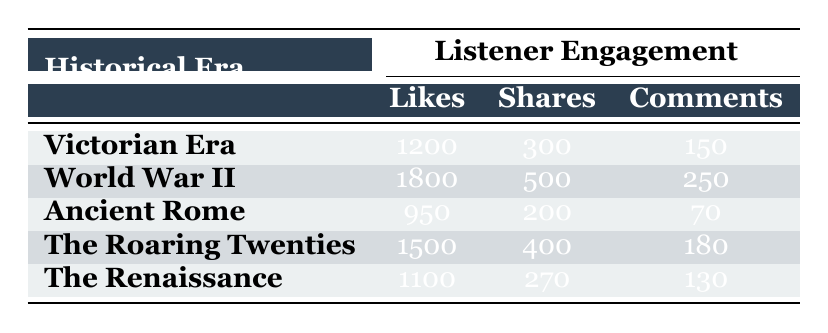What is the total number of likes for the podcast episodes about the Victorian Era and the Roaring Twenties combined? The number of likes for the Victorian Era episode "The Mysteries of Victorian London" is 1200, and for "Jazz and Prohibition" from the Roaring Twenties is 1500. Adding these together gives us 1200 + 1500 = 2700.
Answer: 2700 Which historical era received the lowest number of comments? By comparing the comments for each episode, the Victorian Era has 150 comments, World War II has 250, Ancient Rome has 70, The Roaring Twenties has 180, and The Renaissance has 130. The minimum among these numbers is 70 from Ancient Rome.
Answer: Ancient Rome Did the podcast episode about World War II receive more shares than the episode about the Roaring Twenties? The World War II episode "Stories from the Front Lines" has 500 shares, while "Jazz and Prohibition" from the Roaring Twenties has 400 shares. Since 500 is greater than 400, the statement is true.
Answer: Yes What is the average number of likes across all the podcast episodes? There are 5 podcast episodes: Victorian Era (1200 likes), World War II (1800 likes), Ancient Rome (950 likes), The Roaring Twenties (1500 likes), and The Renaissance (1100 likes). Summing these gives us 1200 + 1800 + 950 + 1500 + 1100 = 5550, and dividing by 5 gives an average of 5550 / 5 = 1110.
Answer: 1110 Is it true that the episode "Life in the Roman Empire" has more likes than "Art and Revolution"? The likes for "Life in the Roman Empire" is 950 and for "Art and Revolution" is 1100. Since 950 is less than 1100, the statement is false.
Answer: No 